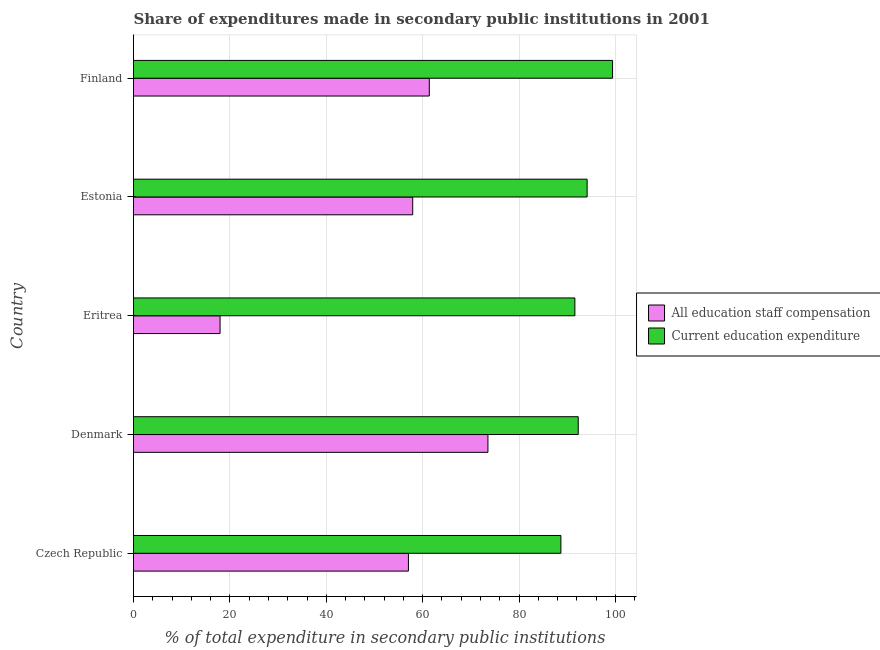How many different coloured bars are there?
Ensure brevity in your answer.  2. Are the number of bars per tick equal to the number of legend labels?
Your response must be concise. Yes. Are the number of bars on each tick of the Y-axis equal?
Your answer should be compact. Yes. What is the label of the 5th group of bars from the top?
Your answer should be compact. Czech Republic. In how many cases, is the number of bars for a given country not equal to the number of legend labels?
Your answer should be compact. 0. What is the expenditure in staff compensation in Eritrea?
Make the answer very short. 17.96. Across all countries, what is the maximum expenditure in education?
Your answer should be very brief. 99.4. Across all countries, what is the minimum expenditure in staff compensation?
Keep it short and to the point. 17.96. In which country was the expenditure in education maximum?
Provide a succinct answer. Finland. In which country was the expenditure in staff compensation minimum?
Keep it short and to the point. Eritrea. What is the total expenditure in education in the graph?
Your response must be concise. 466.06. What is the difference between the expenditure in staff compensation in Denmark and that in Estonia?
Your answer should be compact. 15.61. What is the difference between the expenditure in education in Eritrea and the expenditure in staff compensation in Czech Republic?
Your response must be concise. 34.53. What is the average expenditure in staff compensation per country?
Offer a very short reply. 53.57. What is the difference between the expenditure in education and expenditure in staff compensation in Czech Republic?
Your response must be concise. 31.63. In how many countries, is the expenditure in education greater than 68 %?
Your answer should be very brief. 5. What is the difference between the highest and the second highest expenditure in education?
Give a very brief answer. 5.28. What is the difference between the highest and the lowest expenditure in staff compensation?
Your answer should be compact. 55.58. Is the sum of the expenditure in education in Eritrea and Estonia greater than the maximum expenditure in staff compensation across all countries?
Provide a succinct answer. Yes. What does the 1st bar from the top in Finland represents?
Offer a terse response. Current education expenditure. What does the 1st bar from the bottom in Denmark represents?
Provide a succinct answer. All education staff compensation. Are all the bars in the graph horizontal?
Ensure brevity in your answer.  Yes. Are the values on the major ticks of X-axis written in scientific E-notation?
Make the answer very short. No. How are the legend labels stacked?
Offer a very short reply. Vertical. What is the title of the graph?
Your answer should be very brief. Share of expenditures made in secondary public institutions in 2001. Does "Secondary school" appear as one of the legend labels in the graph?
Offer a terse response. No. What is the label or title of the X-axis?
Keep it short and to the point. % of total expenditure in secondary public institutions. What is the label or title of the Y-axis?
Your answer should be very brief. Country. What is the % of total expenditure in secondary public institutions in All education staff compensation in Czech Republic?
Keep it short and to the point. 57.05. What is the % of total expenditure in secondary public institutions in Current education expenditure in Czech Republic?
Your response must be concise. 88.68. What is the % of total expenditure in secondary public institutions in All education staff compensation in Denmark?
Provide a short and direct response. 73.54. What is the % of total expenditure in secondary public institutions of Current education expenditure in Denmark?
Offer a very short reply. 92.28. What is the % of total expenditure in secondary public institutions in All education staff compensation in Eritrea?
Keep it short and to the point. 17.96. What is the % of total expenditure in secondary public institutions of Current education expenditure in Eritrea?
Make the answer very short. 91.58. What is the % of total expenditure in secondary public institutions of All education staff compensation in Estonia?
Offer a very short reply. 57.93. What is the % of total expenditure in secondary public institutions of Current education expenditure in Estonia?
Make the answer very short. 94.12. What is the % of total expenditure in secondary public institutions of All education staff compensation in Finland?
Your answer should be very brief. 61.37. What is the % of total expenditure in secondary public institutions in Current education expenditure in Finland?
Keep it short and to the point. 99.4. Across all countries, what is the maximum % of total expenditure in secondary public institutions in All education staff compensation?
Give a very brief answer. 73.54. Across all countries, what is the maximum % of total expenditure in secondary public institutions of Current education expenditure?
Provide a succinct answer. 99.4. Across all countries, what is the minimum % of total expenditure in secondary public institutions of All education staff compensation?
Your response must be concise. 17.96. Across all countries, what is the minimum % of total expenditure in secondary public institutions of Current education expenditure?
Make the answer very short. 88.68. What is the total % of total expenditure in secondary public institutions of All education staff compensation in the graph?
Your response must be concise. 267.85. What is the total % of total expenditure in secondary public institutions of Current education expenditure in the graph?
Provide a short and direct response. 466.06. What is the difference between the % of total expenditure in secondary public institutions of All education staff compensation in Czech Republic and that in Denmark?
Make the answer very short. -16.49. What is the difference between the % of total expenditure in secondary public institutions of Current education expenditure in Czech Republic and that in Denmark?
Your answer should be compact. -3.6. What is the difference between the % of total expenditure in secondary public institutions in All education staff compensation in Czech Republic and that in Eritrea?
Give a very brief answer. 39.09. What is the difference between the % of total expenditure in secondary public institutions in Current education expenditure in Czech Republic and that in Eritrea?
Ensure brevity in your answer.  -2.9. What is the difference between the % of total expenditure in secondary public institutions in All education staff compensation in Czech Republic and that in Estonia?
Ensure brevity in your answer.  -0.88. What is the difference between the % of total expenditure in secondary public institutions of Current education expenditure in Czech Republic and that in Estonia?
Make the answer very short. -5.44. What is the difference between the % of total expenditure in secondary public institutions in All education staff compensation in Czech Republic and that in Finland?
Keep it short and to the point. -4.33. What is the difference between the % of total expenditure in secondary public institutions in Current education expenditure in Czech Republic and that in Finland?
Your answer should be very brief. -10.72. What is the difference between the % of total expenditure in secondary public institutions of All education staff compensation in Denmark and that in Eritrea?
Ensure brevity in your answer.  55.58. What is the difference between the % of total expenditure in secondary public institutions in Current education expenditure in Denmark and that in Eritrea?
Make the answer very short. 0.7. What is the difference between the % of total expenditure in secondary public institutions of All education staff compensation in Denmark and that in Estonia?
Make the answer very short. 15.61. What is the difference between the % of total expenditure in secondary public institutions of Current education expenditure in Denmark and that in Estonia?
Your answer should be compact. -1.84. What is the difference between the % of total expenditure in secondary public institutions of All education staff compensation in Denmark and that in Finland?
Ensure brevity in your answer.  12.17. What is the difference between the % of total expenditure in secondary public institutions of Current education expenditure in Denmark and that in Finland?
Give a very brief answer. -7.12. What is the difference between the % of total expenditure in secondary public institutions in All education staff compensation in Eritrea and that in Estonia?
Make the answer very short. -39.97. What is the difference between the % of total expenditure in secondary public institutions in Current education expenditure in Eritrea and that in Estonia?
Your answer should be very brief. -2.54. What is the difference between the % of total expenditure in secondary public institutions in All education staff compensation in Eritrea and that in Finland?
Give a very brief answer. -43.41. What is the difference between the % of total expenditure in secondary public institutions of Current education expenditure in Eritrea and that in Finland?
Offer a very short reply. -7.82. What is the difference between the % of total expenditure in secondary public institutions in All education staff compensation in Estonia and that in Finland?
Offer a very short reply. -3.44. What is the difference between the % of total expenditure in secondary public institutions in Current education expenditure in Estonia and that in Finland?
Your answer should be compact. -5.28. What is the difference between the % of total expenditure in secondary public institutions of All education staff compensation in Czech Republic and the % of total expenditure in secondary public institutions of Current education expenditure in Denmark?
Ensure brevity in your answer.  -35.23. What is the difference between the % of total expenditure in secondary public institutions of All education staff compensation in Czech Republic and the % of total expenditure in secondary public institutions of Current education expenditure in Eritrea?
Provide a short and direct response. -34.53. What is the difference between the % of total expenditure in secondary public institutions in All education staff compensation in Czech Republic and the % of total expenditure in secondary public institutions in Current education expenditure in Estonia?
Your answer should be very brief. -37.07. What is the difference between the % of total expenditure in secondary public institutions of All education staff compensation in Czech Republic and the % of total expenditure in secondary public institutions of Current education expenditure in Finland?
Provide a short and direct response. -42.35. What is the difference between the % of total expenditure in secondary public institutions in All education staff compensation in Denmark and the % of total expenditure in secondary public institutions in Current education expenditure in Eritrea?
Provide a succinct answer. -18.04. What is the difference between the % of total expenditure in secondary public institutions in All education staff compensation in Denmark and the % of total expenditure in secondary public institutions in Current education expenditure in Estonia?
Your answer should be very brief. -20.58. What is the difference between the % of total expenditure in secondary public institutions in All education staff compensation in Denmark and the % of total expenditure in secondary public institutions in Current education expenditure in Finland?
Give a very brief answer. -25.86. What is the difference between the % of total expenditure in secondary public institutions in All education staff compensation in Eritrea and the % of total expenditure in secondary public institutions in Current education expenditure in Estonia?
Your answer should be very brief. -76.16. What is the difference between the % of total expenditure in secondary public institutions of All education staff compensation in Eritrea and the % of total expenditure in secondary public institutions of Current education expenditure in Finland?
Give a very brief answer. -81.44. What is the difference between the % of total expenditure in secondary public institutions of All education staff compensation in Estonia and the % of total expenditure in secondary public institutions of Current education expenditure in Finland?
Make the answer very short. -41.47. What is the average % of total expenditure in secondary public institutions in All education staff compensation per country?
Your answer should be very brief. 53.57. What is the average % of total expenditure in secondary public institutions in Current education expenditure per country?
Offer a terse response. 93.21. What is the difference between the % of total expenditure in secondary public institutions of All education staff compensation and % of total expenditure in secondary public institutions of Current education expenditure in Czech Republic?
Your response must be concise. -31.63. What is the difference between the % of total expenditure in secondary public institutions of All education staff compensation and % of total expenditure in secondary public institutions of Current education expenditure in Denmark?
Your response must be concise. -18.74. What is the difference between the % of total expenditure in secondary public institutions in All education staff compensation and % of total expenditure in secondary public institutions in Current education expenditure in Eritrea?
Keep it short and to the point. -73.62. What is the difference between the % of total expenditure in secondary public institutions of All education staff compensation and % of total expenditure in secondary public institutions of Current education expenditure in Estonia?
Offer a very short reply. -36.19. What is the difference between the % of total expenditure in secondary public institutions in All education staff compensation and % of total expenditure in secondary public institutions in Current education expenditure in Finland?
Offer a very short reply. -38.03. What is the ratio of the % of total expenditure in secondary public institutions of All education staff compensation in Czech Republic to that in Denmark?
Your answer should be very brief. 0.78. What is the ratio of the % of total expenditure in secondary public institutions of Current education expenditure in Czech Republic to that in Denmark?
Offer a terse response. 0.96. What is the ratio of the % of total expenditure in secondary public institutions of All education staff compensation in Czech Republic to that in Eritrea?
Provide a succinct answer. 3.18. What is the ratio of the % of total expenditure in secondary public institutions of Current education expenditure in Czech Republic to that in Eritrea?
Your answer should be compact. 0.97. What is the ratio of the % of total expenditure in secondary public institutions in All education staff compensation in Czech Republic to that in Estonia?
Make the answer very short. 0.98. What is the ratio of the % of total expenditure in secondary public institutions of Current education expenditure in Czech Republic to that in Estonia?
Offer a very short reply. 0.94. What is the ratio of the % of total expenditure in secondary public institutions in All education staff compensation in Czech Republic to that in Finland?
Your answer should be compact. 0.93. What is the ratio of the % of total expenditure in secondary public institutions in Current education expenditure in Czech Republic to that in Finland?
Provide a succinct answer. 0.89. What is the ratio of the % of total expenditure in secondary public institutions in All education staff compensation in Denmark to that in Eritrea?
Offer a terse response. 4.1. What is the ratio of the % of total expenditure in secondary public institutions in Current education expenditure in Denmark to that in Eritrea?
Ensure brevity in your answer.  1.01. What is the ratio of the % of total expenditure in secondary public institutions in All education staff compensation in Denmark to that in Estonia?
Make the answer very short. 1.27. What is the ratio of the % of total expenditure in secondary public institutions in Current education expenditure in Denmark to that in Estonia?
Provide a short and direct response. 0.98. What is the ratio of the % of total expenditure in secondary public institutions in All education staff compensation in Denmark to that in Finland?
Offer a terse response. 1.2. What is the ratio of the % of total expenditure in secondary public institutions in Current education expenditure in Denmark to that in Finland?
Provide a short and direct response. 0.93. What is the ratio of the % of total expenditure in secondary public institutions in All education staff compensation in Eritrea to that in Estonia?
Give a very brief answer. 0.31. What is the ratio of the % of total expenditure in secondary public institutions in Current education expenditure in Eritrea to that in Estonia?
Keep it short and to the point. 0.97. What is the ratio of the % of total expenditure in secondary public institutions of All education staff compensation in Eritrea to that in Finland?
Your answer should be very brief. 0.29. What is the ratio of the % of total expenditure in secondary public institutions of Current education expenditure in Eritrea to that in Finland?
Provide a succinct answer. 0.92. What is the ratio of the % of total expenditure in secondary public institutions of All education staff compensation in Estonia to that in Finland?
Provide a short and direct response. 0.94. What is the ratio of the % of total expenditure in secondary public institutions of Current education expenditure in Estonia to that in Finland?
Ensure brevity in your answer.  0.95. What is the difference between the highest and the second highest % of total expenditure in secondary public institutions of All education staff compensation?
Your answer should be compact. 12.17. What is the difference between the highest and the second highest % of total expenditure in secondary public institutions in Current education expenditure?
Provide a short and direct response. 5.28. What is the difference between the highest and the lowest % of total expenditure in secondary public institutions in All education staff compensation?
Give a very brief answer. 55.58. What is the difference between the highest and the lowest % of total expenditure in secondary public institutions in Current education expenditure?
Offer a very short reply. 10.72. 